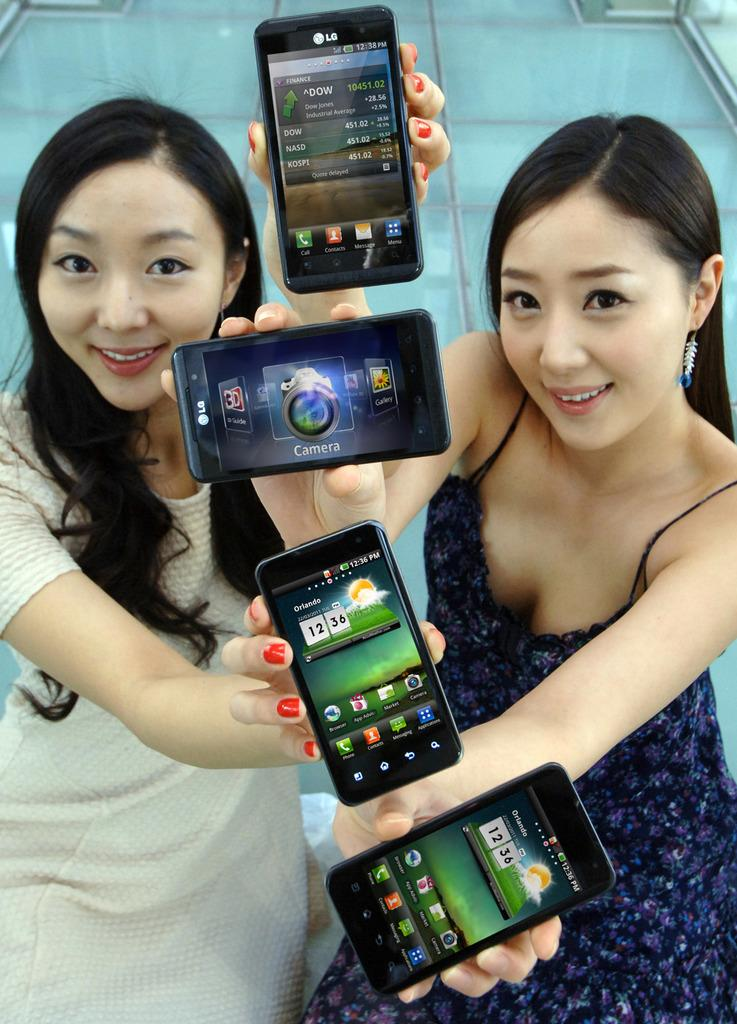<image>
Provide a brief description of the given image. Two women are holding up four different phones up to a camera. 